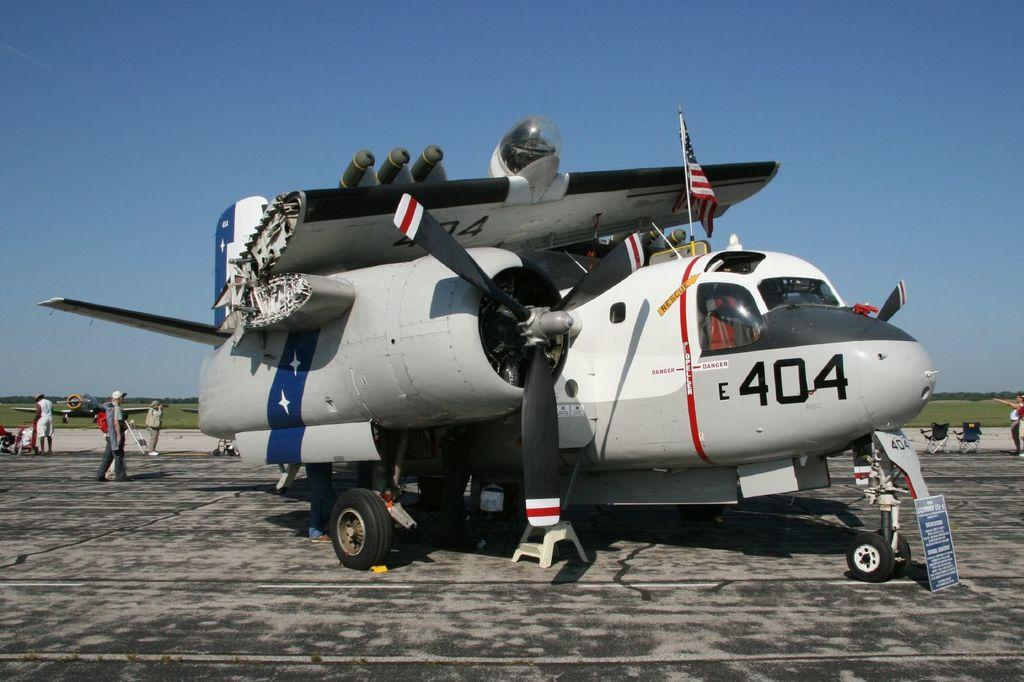What is the main subject of the image? The main subject of the image is an airplane on the runway. Are there any people present in the image? Yes, there are people standing on the runway on the left side. What can be seen in the background of the image? The sky is visible in the background of the image. What type of glass can be seen in the hands of the people on the runway? There is no glass present in the image, nor are there any hands visible. 